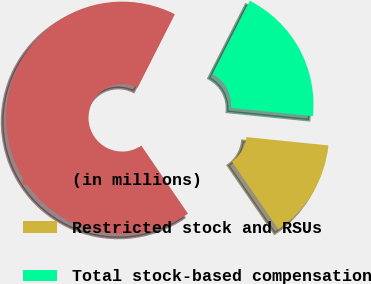Convert chart to OTSL. <chart><loc_0><loc_0><loc_500><loc_500><pie_chart><fcel>(in millions)<fcel>Restricted stock and RSUs<fcel>Total stock-based compensation<nl><fcel>67.04%<fcel>13.82%<fcel>19.14%<nl></chart> 